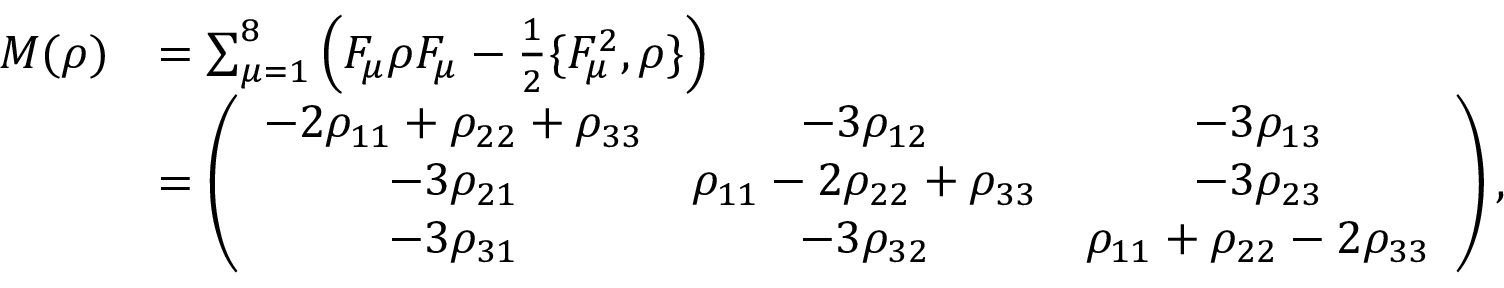<formula> <loc_0><loc_0><loc_500><loc_500>\begin{array} { r l } { M ( \rho ) } & { = \sum _ { \mu = 1 } ^ { 8 } \left ( F _ { \mu } \rho F _ { \mu } - \frac { 1 } { 2 } \{ F _ { \mu } ^ { 2 } , \rho \} \right ) } \\ & { = \left ( \begin{array} { c c c } { - 2 \rho _ { 1 1 } + \rho _ { 2 2 } + \rho _ { 3 3 } } & { - 3 \rho _ { 1 2 } } & { - 3 \rho _ { 1 3 } } \\ { - 3 \rho _ { 2 1 } } & { \rho _ { 1 1 } - 2 \rho _ { 2 2 } + \rho _ { 3 3 } } & { - 3 \rho _ { 2 3 } } \\ { - 3 \rho _ { 3 1 } } & { - 3 \rho _ { 3 2 } } & { \rho _ { 1 1 } + \rho _ { 2 2 } - 2 \rho _ { 3 3 } } \end{array} \right ) , } \end{array}</formula> 